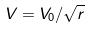Convert formula to latex. <formula><loc_0><loc_0><loc_500><loc_500>V = V _ { 0 } / \sqrt { r }</formula> 